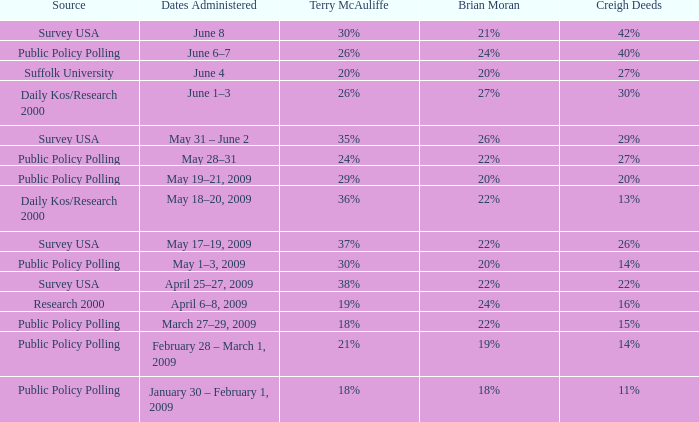From which source does brian moran have a 19%? Public Policy Polling. 